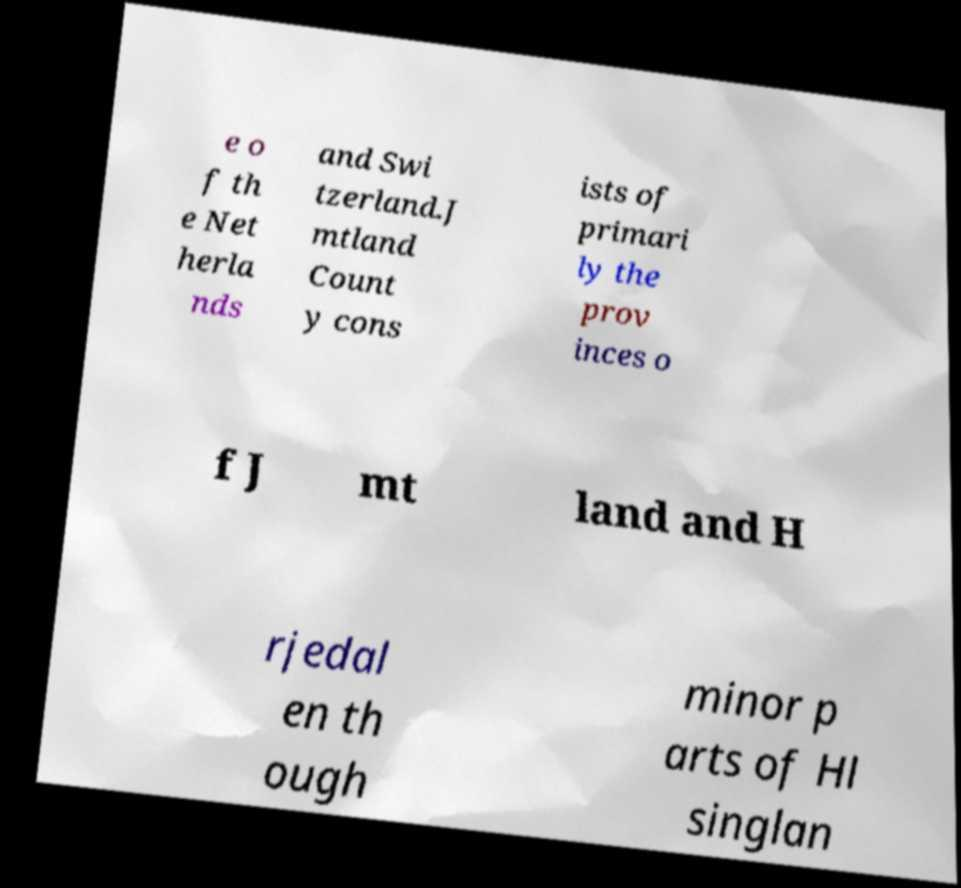Could you extract and type out the text from this image? e o f th e Net herla nds and Swi tzerland.J mtland Count y cons ists of primari ly the prov inces o f J mt land and H rjedal en th ough minor p arts of Hl singlan 